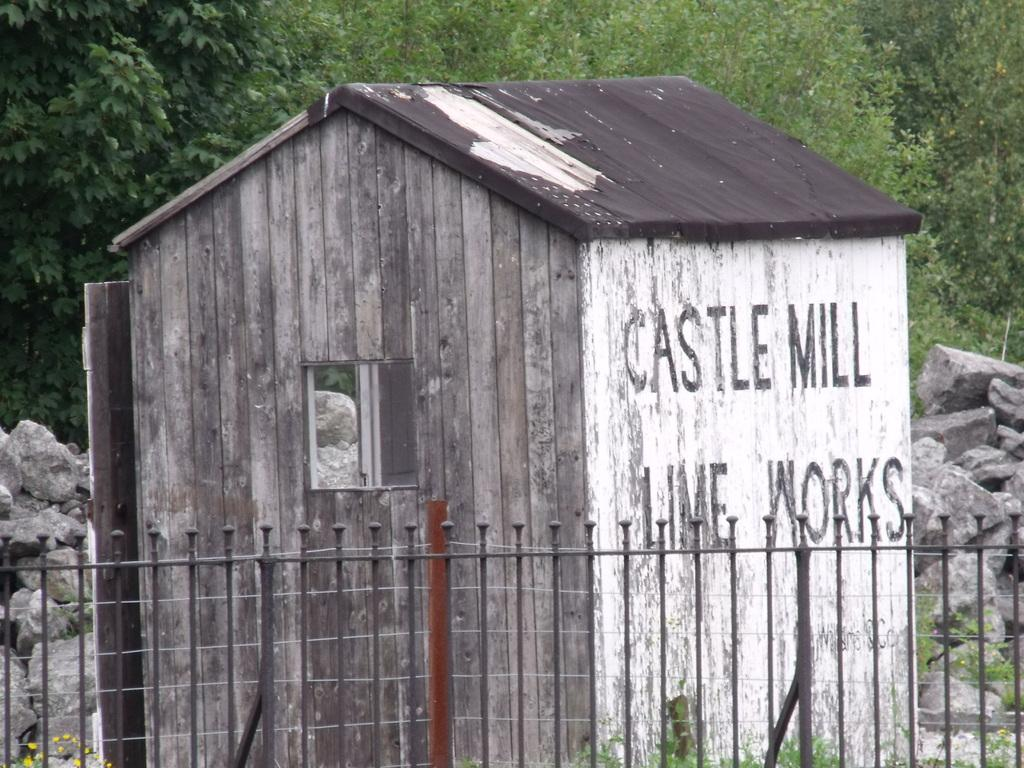<image>
Present a compact description of the photo's key features. old wooden building labeled castle mill lime works behind a fence 